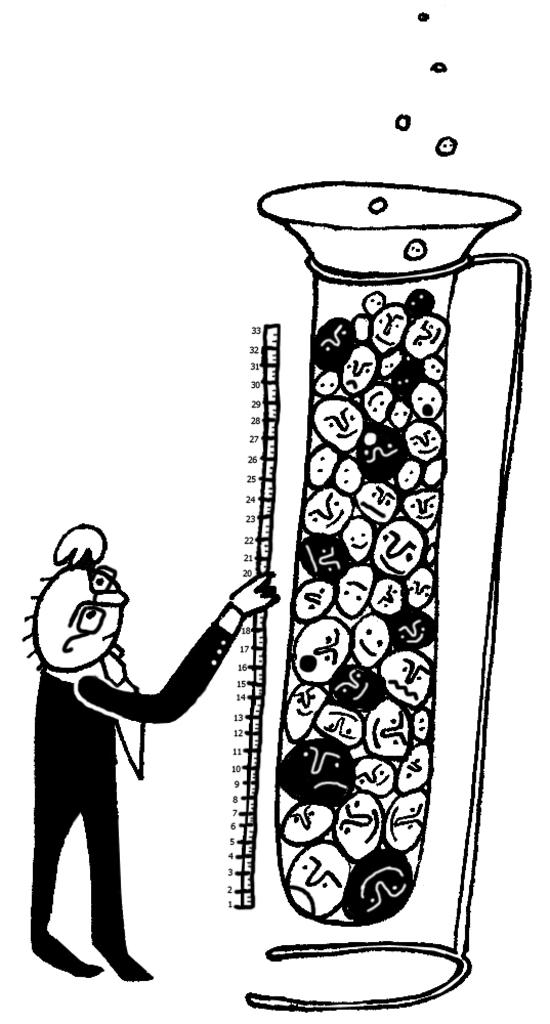What type of drawing is depicted in the image? The image contains a sketch of a cartoon. Can you describe the style or genre of the cartoon? The provided facts do not specify the style or genre of the cartoon. What medium might have been used to create the sketch? The medium used to create the sketch is not mentioned in the provided facts. What type of flock can be seen flying in the background of the image? There is no background or flock visible in the image, as it only contains a sketch of a cartoon. 